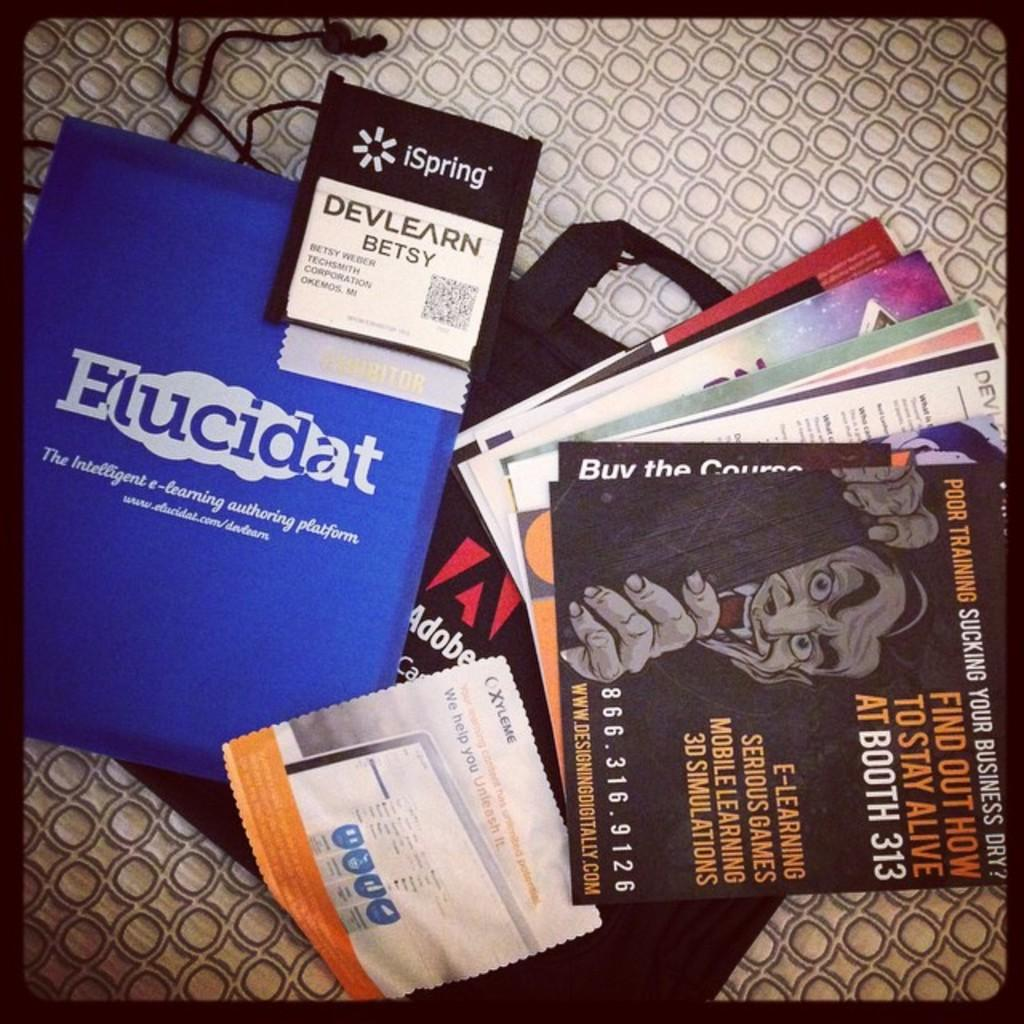What is one of the objects visible in the image? There is a bag in the image. Are there any other items besides the bag in the image? Yes, there are posters in the image. Can you describe the color of one of the objects in the image? There is a blue object in the image. Where are all the objects located in the image? All objects are on a surface. What type of chalk is being used to write on the bag in the image? There is no chalk present in the image, and the bag is not being written on. 